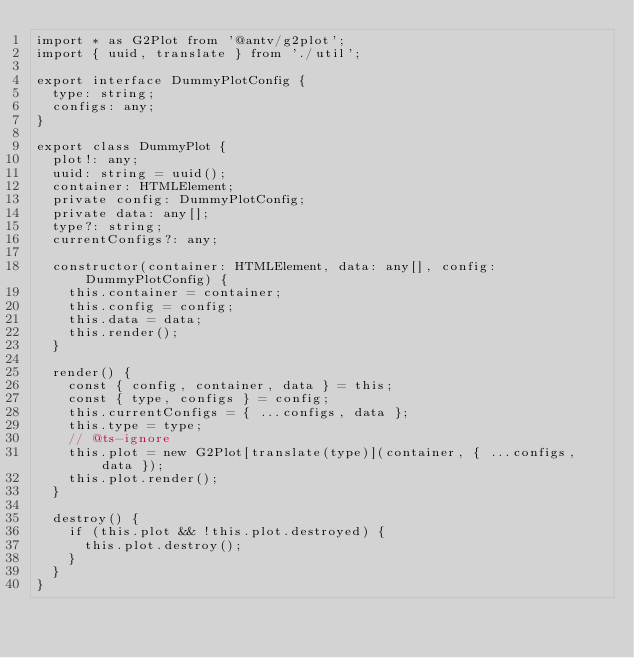<code> <loc_0><loc_0><loc_500><loc_500><_TypeScript_>import * as G2Plot from '@antv/g2plot';
import { uuid, translate } from './util';

export interface DummyPlotConfig {
  type: string;
  configs: any;
}

export class DummyPlot {
  plot!: any;
  uuid: string = uuid();
  container: HTMLElement;
  private config: DummyPlotConfig;
  private data: any[];
  type?: string;
  currentConfigs?: any;

  constructor(container: HTMLElement, data: any[], config: DummyPlotConfig) {
    this.container = container;
    this.config = config;
    this.data = data;
    this.render();
  }

  render() {
    const { config, container, data } = this;
    const { type, configs } = config;
    this.currentConfigs = { ...configs, data };
    this.type = type;
    // @ts-ignore
    this.plot = new G2Plot[translate(type)](container, { ...configs, data });
    this.plot.render();
  }

  destroy() {
    if (this.plot && !this.plot.destroyed) {
      this.plot.destroy();
    }
  }
}
</code> 